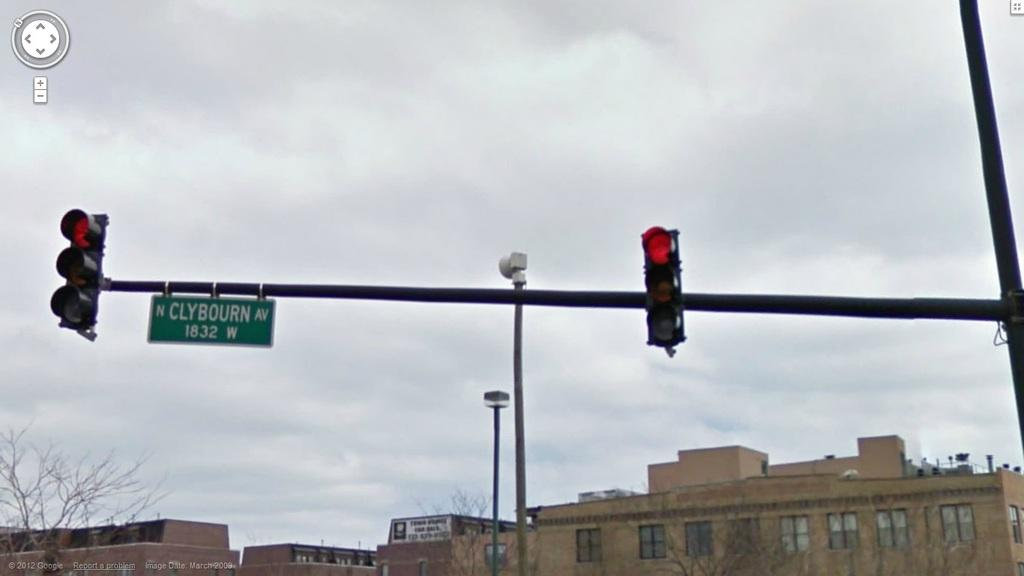Provide a one-sentence caption for the provided image. A red traffic light on North Clybourn Avenue. 